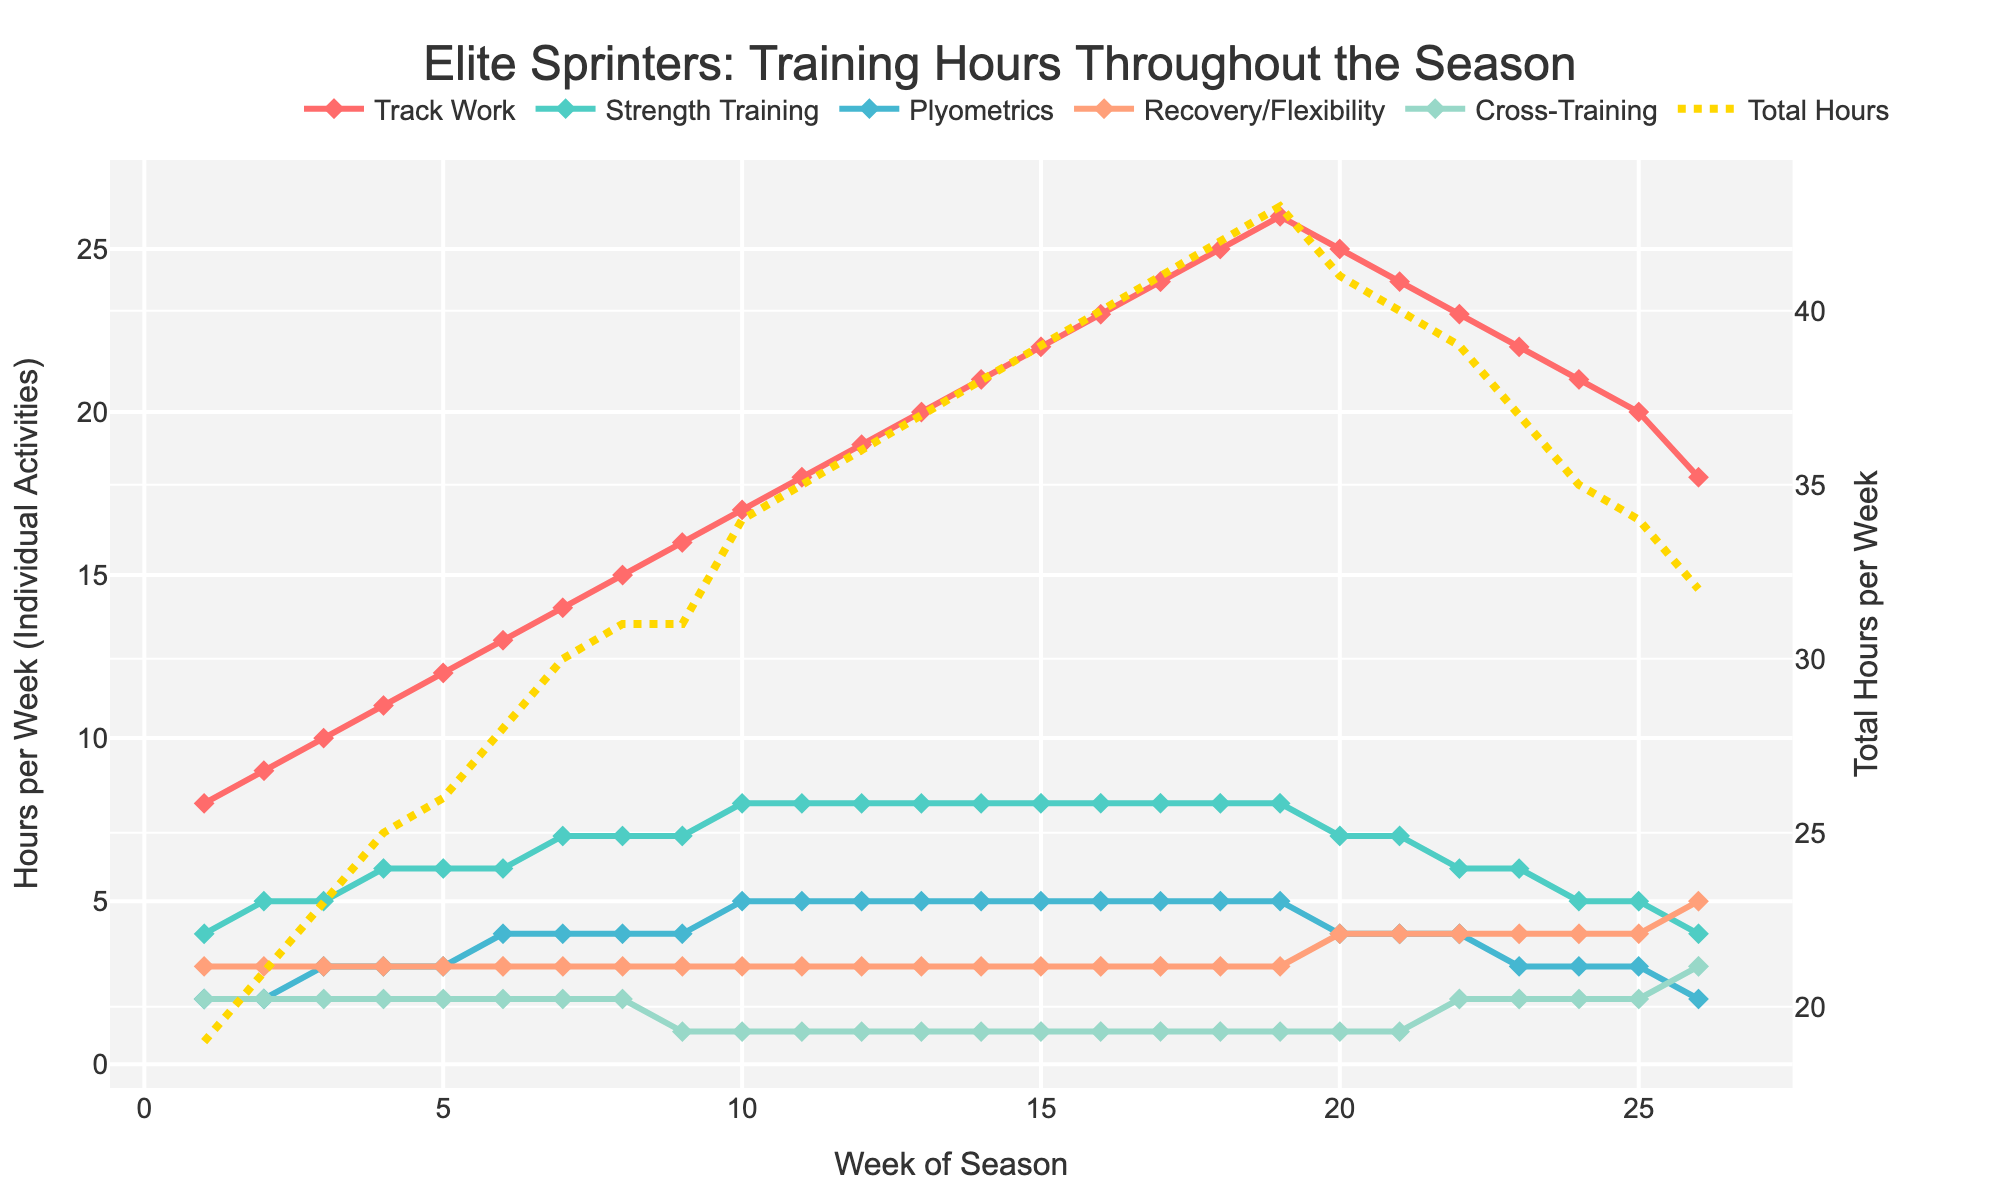What is the range of total training hours per week throughout the season? To determine the range, we need to find the difference between the maximum and minimum total training hours. From the figure, the maximum total training hours (Week 19) are 43 hours (26+8+5+3+1) and the minimum (Week 1) is 19 hours (8+4+2+3+2). So, the range is 43 - 19 = 24 hours.
Answer: 24 hours In which week does Track Work training alone equal the total number of hours of all other training types combined? We need to find a week where the hours in Track Work equal the sum of the other four training types. In Week 16, the Track Work training is 23 hours. Summing up the other training types, we get 8 (Strength Training) + 5 (Plyometrics) + 3 (Recovery/Flexibility) + 1 (Cross-Training) = 17 hours, which is not equal. In fact, there isn't any week meeting this criteria, so such a week doesn't exist in the figure.
Answer: None During which weeks does Recovery/Flexibility training show an increase compared to the previous week? We observe the Recovery/Flexibility values for each week and compare them with the previous week. The weeks where it increases compared to the previous week are: Week 20 (4 > 3), Week 21 (4 = 4), and Week 26 (5 > 4).
Answer: Weeks 20, 21, 26 Which training type experiences the least variation in weekly hours throughout the season? To determine the least variation, we look at the differences in hours for each training type across the weeks. Cross-Training has the least variation (ranges between 1 and 3 hours), while the other types show much wider ranges.
Answer: Cross-Training How do the training hours for Plyometrics change from Weeks 12 to 14? Based on the figure, in Week 12 Plyometrics is at 5 hours, in Week 13 it remains at 5 hours, and in Week 14 it remains stable at 5 hours. There is no change in this period.
Answer: No change How does the total training load trend from Week 20 to Week 26? To determine the trend, analyze the total hours (computed previously from the respective weeks). Observe that from Week 20 (25 hours), Week 21 (24 hours), Week 22 (23 hours), Week 23 (22 hours), Week 24 (21 hours), Week 25 (20 hours), to Week 26 (18 hours), the trend is consistently downward.
Answer: Decreasing Among the training types, which one has the steepest increase in hours in the first 10 weeks? Observe the slopes for each training type. Track Work goes from 8 to 17 (increases by 9), Strength Training from 4 to 8 (increases by 4), Plyometrics from 2 to 5 (increases by 3), Recovery/Flexibility from 3 to 3 (no increase), and Cross-Training from 2 to 1 (actually decreases). Track Work has the steepest increase.
Answer: Track Work 